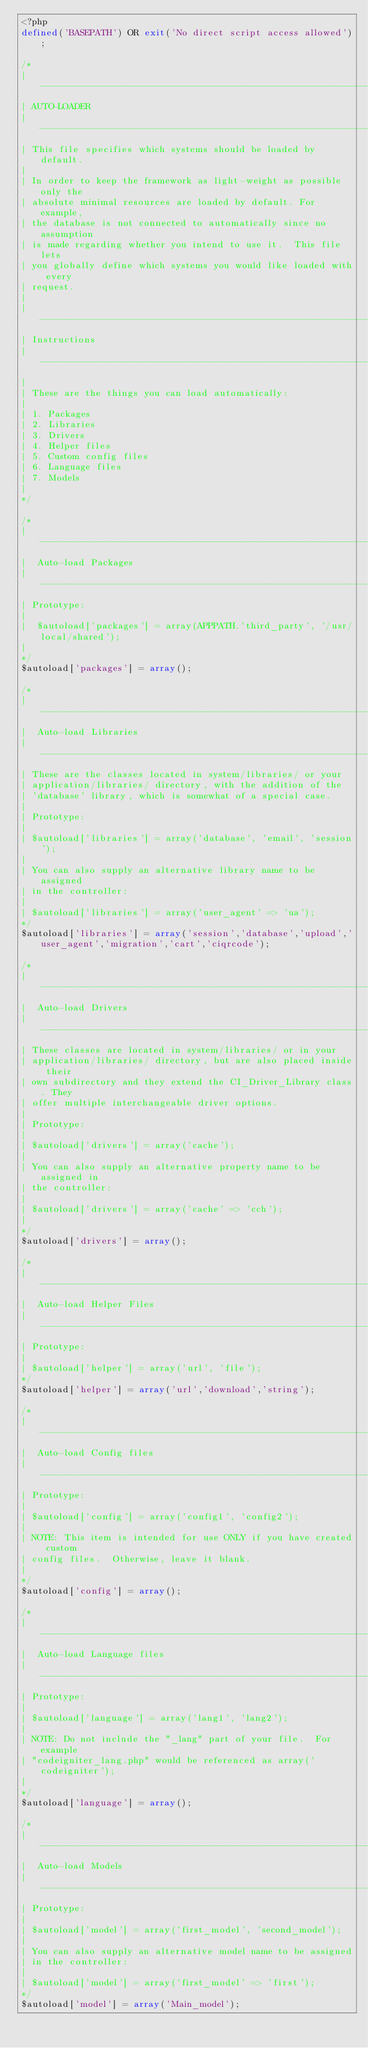Convert code to text. <code><loc_0><loc_0><loc_500><loc_500><_PHP_><?php
defined('BASEPATH') OR exit('No direct script access allowed');

/*
| -------------------------------------------------------------------
| AUTO-LOADER
| -------------------------------------------------------------------
| This file specifies which systems should be loaded by default.
|
| In order to keep the framework as light-weight as possible only the
| absolute minimal resources are loaded by default. For example,
| the database is not connected to automatically since no assumption
| is made regarding whether you intend to use it.  This file lets
| you globally define which systems you would like loaded with every
| request.
|
| -------------------------------------------------------------------
| Instructions
| -------------------------------------------------------------------
|
| These are the things you can load automatically:
|
| 1. Packages
| 2. Libraries
| 3. Drivers
| 4. Helper files
| 5. Custom config files
| 6. Language files
| 7. Models
|
*/

/*
| -------------------------------------------------------------------
|  Auto-load Packages
| -------------------------------------------------------------------
| Prototype:
|
|  $autoload['packages'] = array(APPPATH.'third_party', '/usr/local/shared');
|
*/
$autoload['packages'] = array();

/*
| -------------------------------------------------------------------
|  Auto-load Libraries
| -------------------------------------------------------------------
| These are the classes located in system/libraries/ or your
| application/libraries/ directory, with the addition of the
| 'database' library, which is somewhat of a special case.
|
| Prototype:
|
|	$autoload['libraries'] = array('database', 'email', 'session');
|
| You can also supply an alternative library name to be assigned
| in the controller:
|
|	$autoload['libraries'] = array('user_agent' => 'ua');
*/
$autoload['libraries'] = array('session','database','upload','user_agent','migration','cart','ciqrcode');

/*
| -------------------------------------------------------------------
|  Auto-load Drivers
| -------------------------------------------------------------------
| These classes are located in system/libraries/ or in your
| application/libraries/ directory, but are also placed inside their
| own subdirectory and they extend the CI_Driver_Library class. They
| offer multiple interchangeable driver options.
|
| Prototype:
|
|	$autoload['drivers'] = array('cache');
|
| You can also supply an alternative property name to be assigned in
| the controller:
|
|	$autoload['drivers'] = array('cache' => 'cch');
|
*/
$autoload['drivers'] = array();

/*
| -------------------------------------------------------------------
|  Auto-load Helper Files
| -------------------------------------------------------------------
| Prototype:
|
|	$autoload['helper'] = array('url', 'file');
*/
$autoload['helper'] = array('url','download','string');

/*
| -------------------------------------------------------------------
|  Auto-load Config files
| -------------------------------------------------------------------
| Prototype:
|
|	$autoload['config'] = array('config1', 'config2');
|
| NOTE: This item is intended for use ONLY if you have created custom
| config files.  Otherwise, leave it blank.
|
*/
$autoload['config'] = array();

/*
| -------------------------------------------------------------------
|  Auto-load Language files
| -------------------------------------------------------------------
| Prototype:
|
|	$autoload['language'] = array('lang1', 'lang2');
|
| NOTE: Do not include the "_lang" part of your file.  For example
| "codeigniter_lang.php" would be referenced as array('codeigniter');
|
*/
$autoload['language'] = array();

/*
| -------------------------------------------------------------------
|  Auto-load Models
| -------------------------------------------------------------------
| Prototype:
|
|	$autoload['model'] = array('first_model', 'second_model');
|
| You can also supply an alternative model name to be assigned
| in the controller:
|
|	$autoload['model'] = array('first_model' => 'first');
*/
$autoload['model'] = array('Main_model');
</code> 